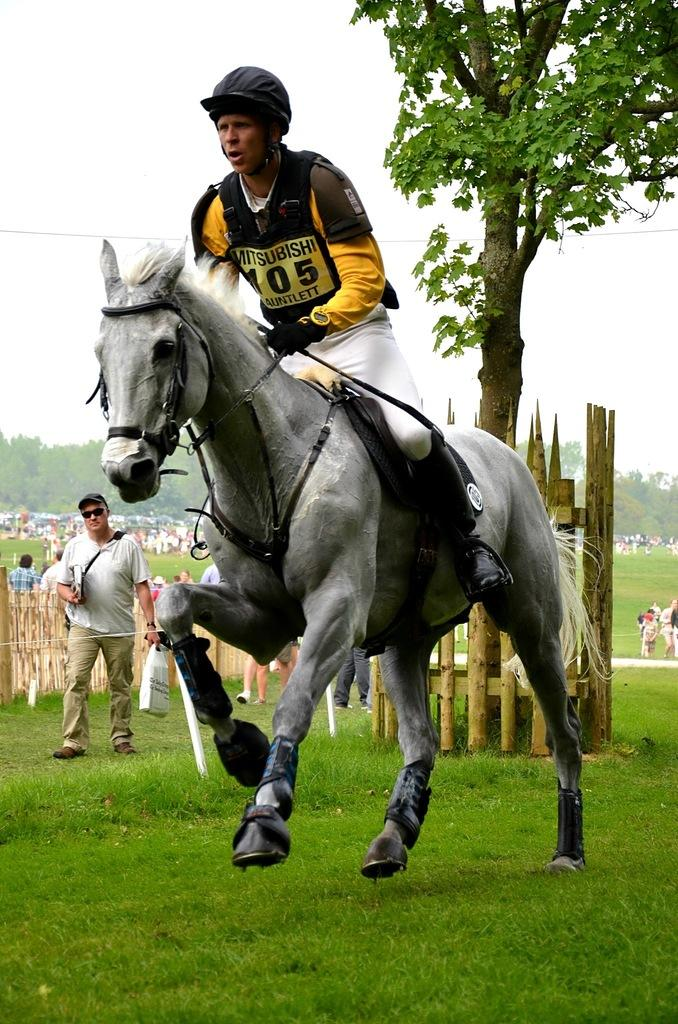What is the main subject of the image? There is a person riding a horse in the image. What can be seen in the background of the image? There are many people, a wooden fence, a tree, and the sky visible in the background of the image. What type of plant is the person holding in their hand while riding the horse? There is no plant visible in the image; the person is riding a horse without holding any plant. How many socks can be seen on the person riding the horse? There is no mention of socks in the image; the person is wearing appropriate attire for horse riding. 